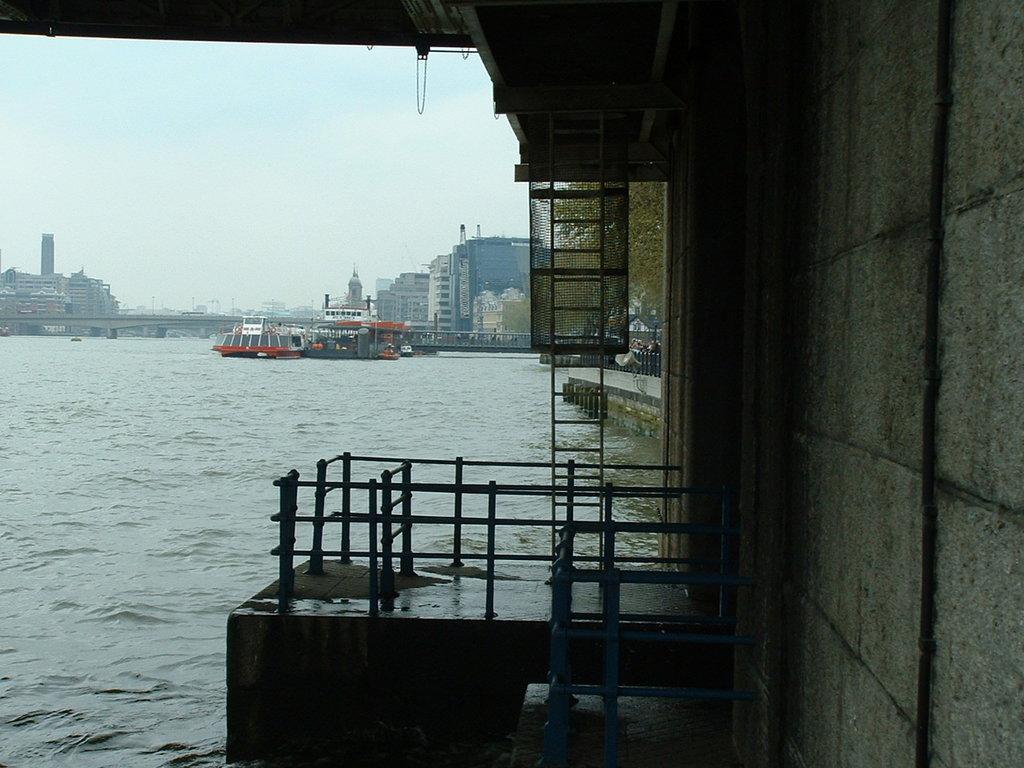Please provide a concise description of this image. In this picture there is a ship on the water. In the background I can see the bridge, buildings, skyscrapers, poles, cranes and other objects. On the left I can see the sky and clouds. On the right I can see the fencing, wall and trees. 